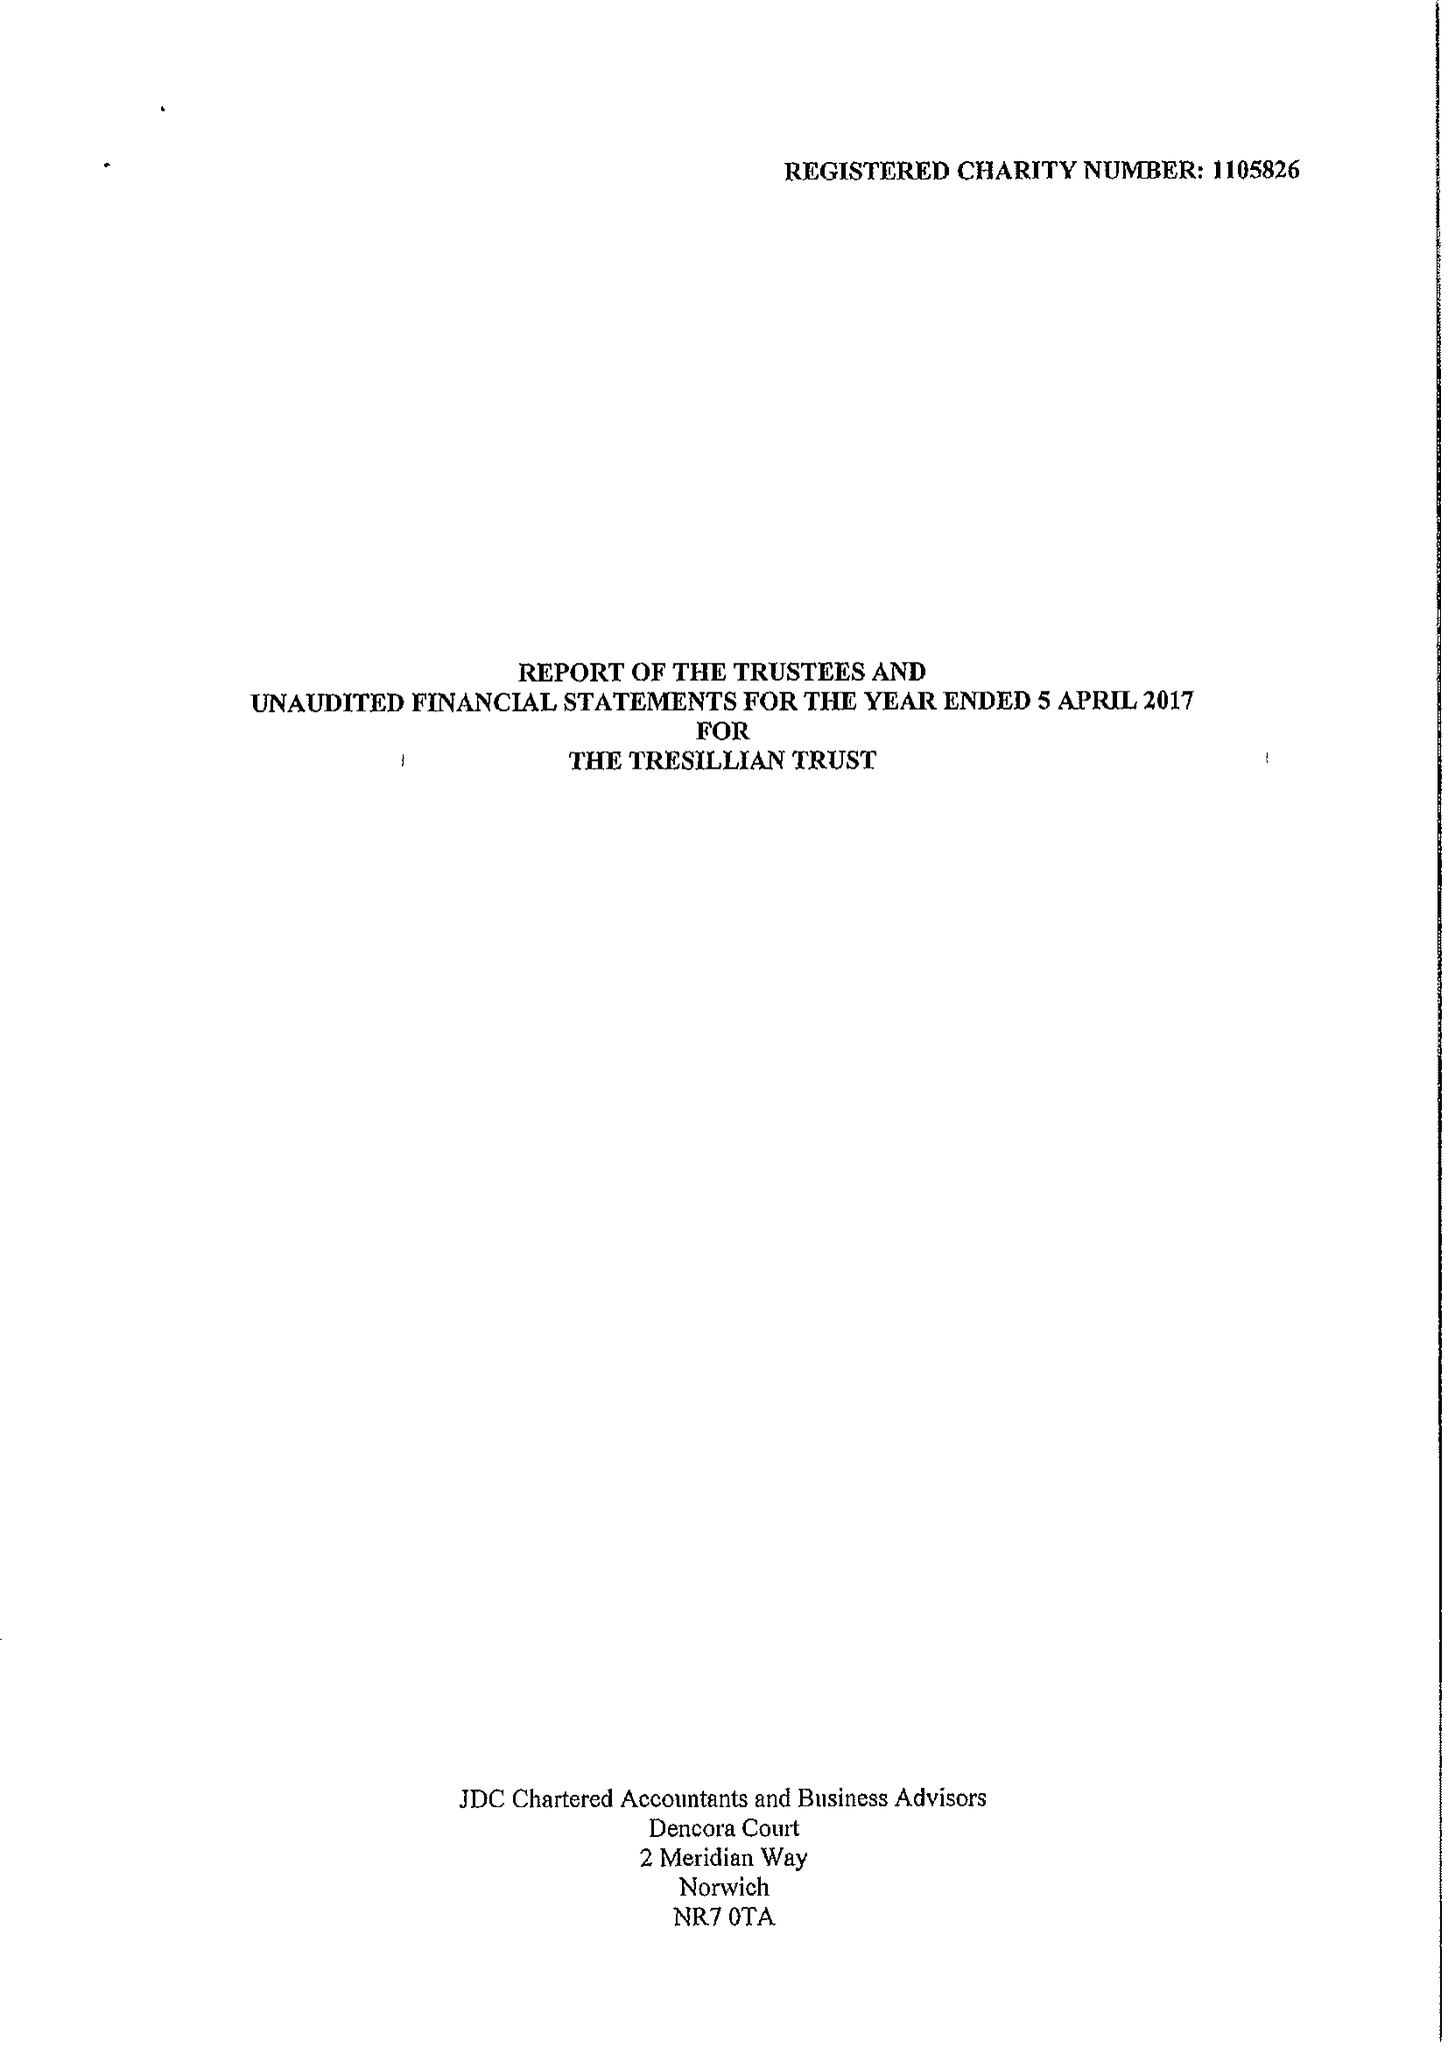What is the value for the address__postcode?
Answer the question using a single word or phrase. SW1H 0NF 